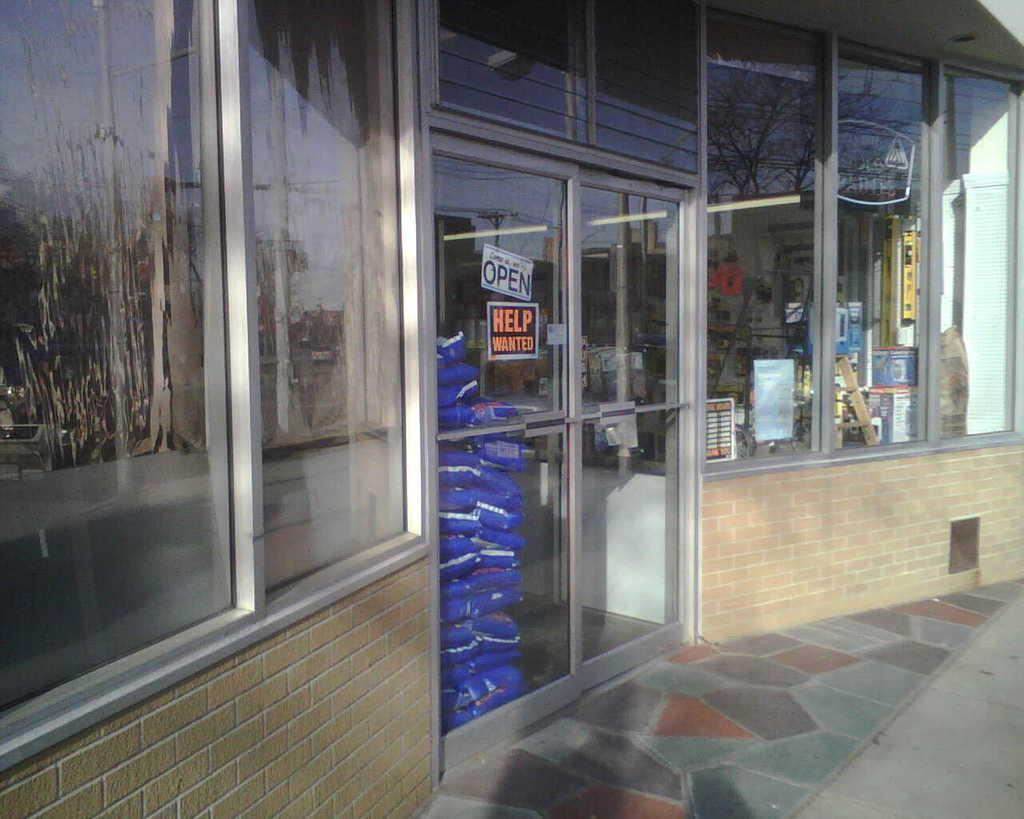Provide a one-sentence caption for the provided image. A help wanted sign is posted on the front door,. 